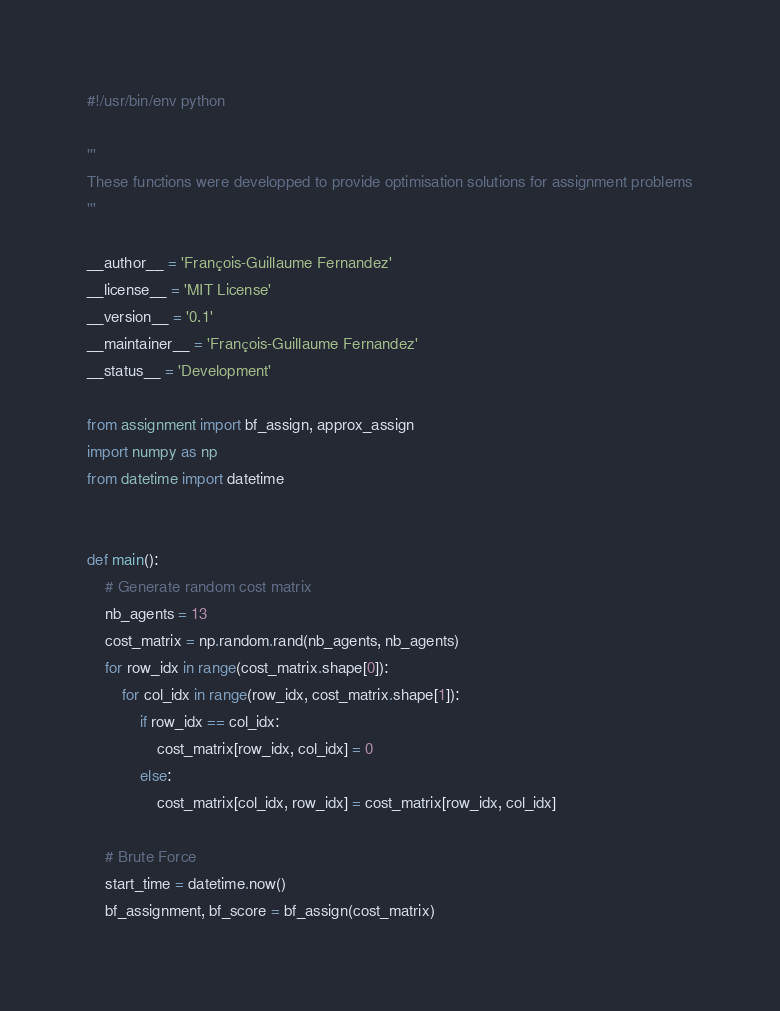Convert code to text. <code><loc_0><loc_0><loc_500><loc_500><_Python_>#!/usr/bin/env python

'''
These functions were developped to provide optimisation solutions for assignment problems
'''

__author__ = 'François-Guillaume Fernandez'
__license__ = 'MIT License'
__version__ = '0.1'
__maintainer__ = 'François-Guillaume Fernandez'
__status__ = 'Development'

from assignment import bf_assign, approx_assign
import numpy as np
from datetime import datetime


def main():
    # Generate random cost matrix
    nb_agents = 13
    cost_matrix = np.random.rand(nb_agents, nb_agents)
    for row_idx in range(cost_matrix.shape[0]):
        for col_idx in range(row_idx, cost_matrix.shape[1]):
            if row_idx == col_idx:
                cost_matrix[row_idx, col_idx] = 0
            else:
                cost_matrix[col_idx, row_idx] = cost_matrix[row_idx, col_idx]

    # Brute Force
    start_time = datetime.now()
    bf_assignment, bf_score = bf_assign(cost_matrix)</code> 